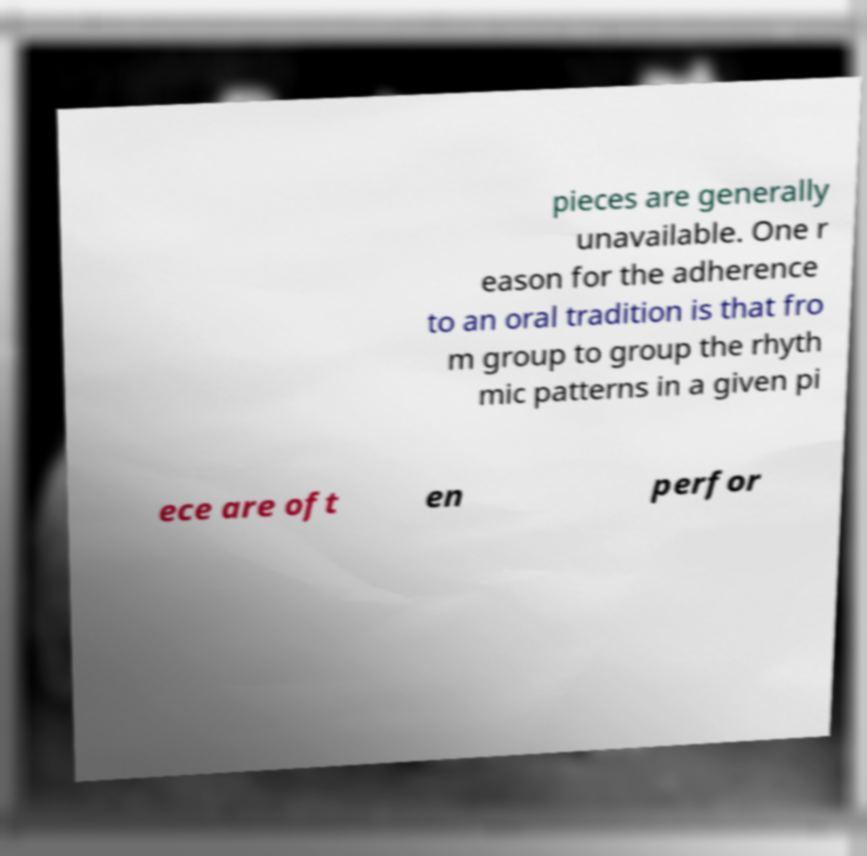Can you accurately transcribe the text from the provided image for me? pieces are generally unavailable. One r eason for the adherence to an oral tradition is that fro m group to group the rhyth mic patterns in a given pi ece are oft en perfor 